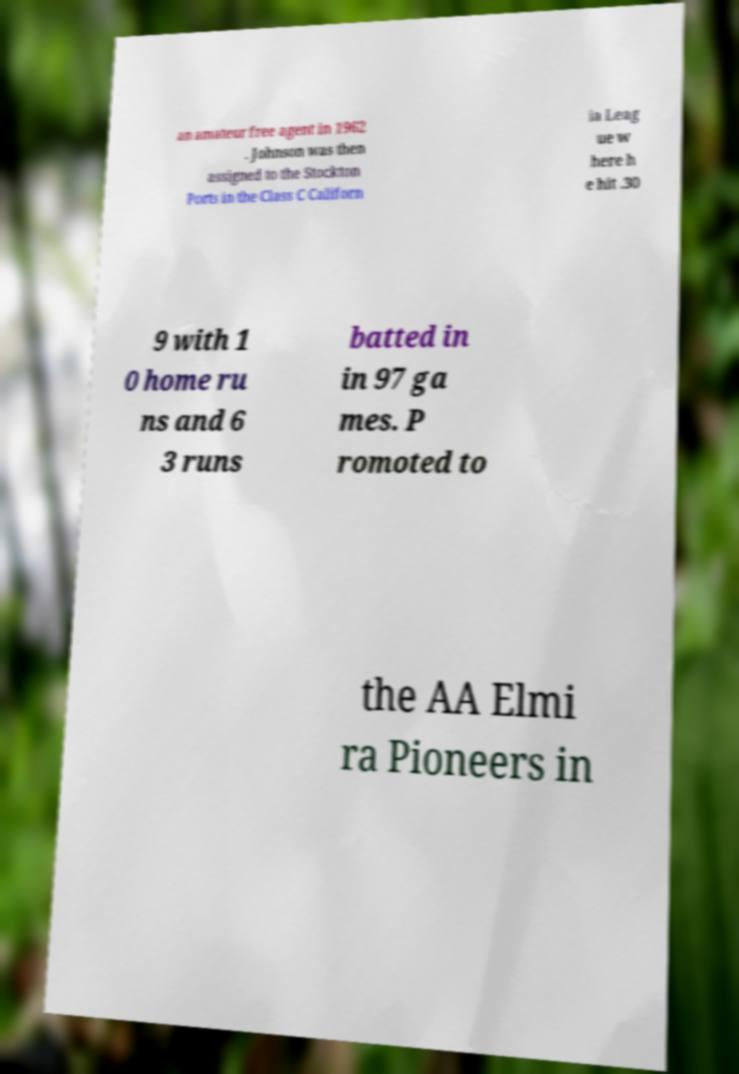I need the written content from this picture converted into text. Can you do that? an amateur free agent in 1962 . Johnson was then assigned to the Stockton Ports in the Class C Californ ia Leag ue w here h e hit .30 9 with 1 0 home ru ns and 6 3 runs batted in in 97 ga mes. P romoted to the AA Elmi ra Pioneers in 